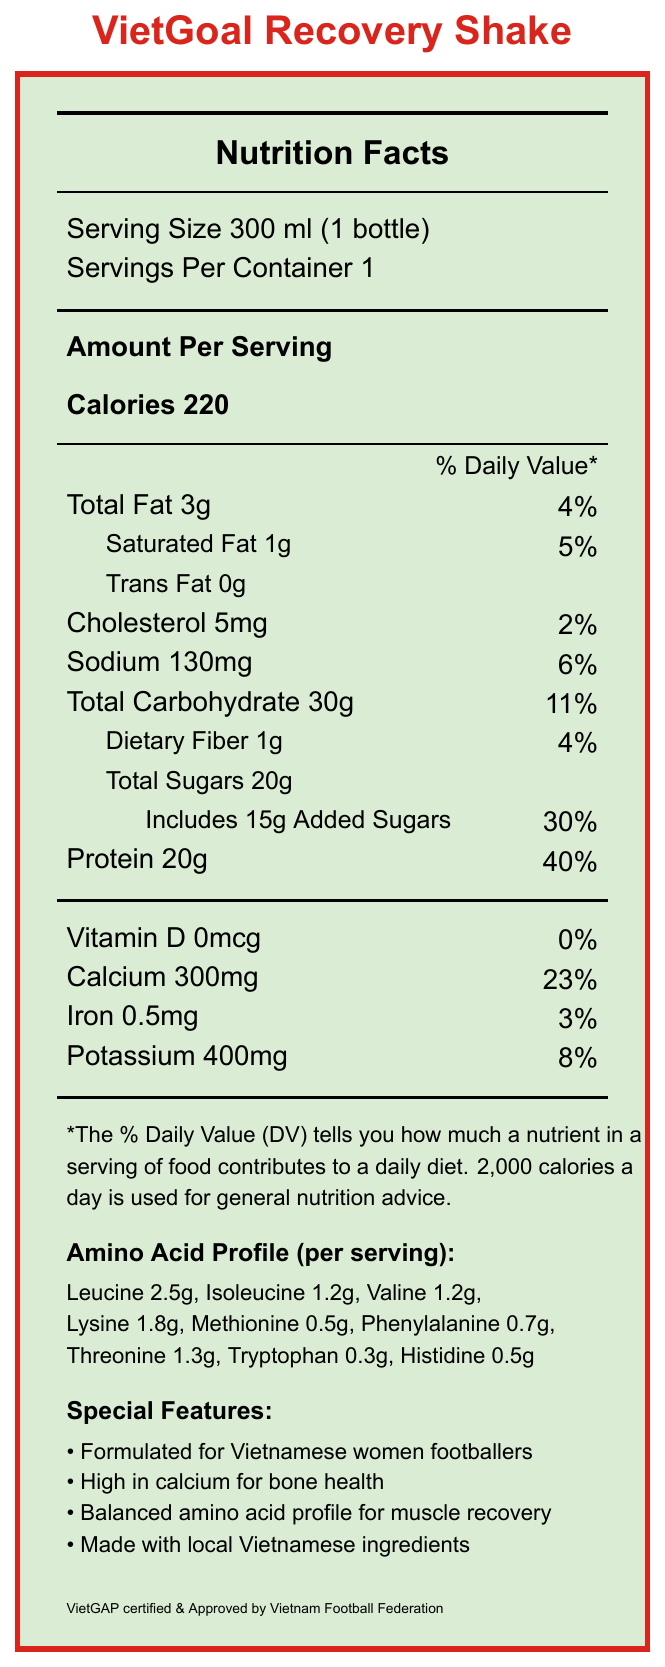what is the serving size? The serving size information is listed in the document as 300 ml (1 bottle).
Answer: 300 ml (1 bottle) how much calcium is in one serving of VietGoal Recovery Shake? The document states that each serving contains 300 mg of calcium.
Answer: 300 mg what is the daily value percentage for protein? The daily value percentage for protein is given as %40 in the nutrition facts section.
Answer: 40% which amino acids are listed in the amino acid profile? The document provides a detailed list of amino acids and their respective amounts in the amino acid profile section.
Answer: Leucine, Isoleucine, Valine, Lysine, Methionine, Phenylalanine, Threonine, Tryptophan, Histidine how many grams of dietary fiber does one serving of the shake contain? The dietary fiber content in one serving is mentioned as 1g.
Answer: 1g what is the percentage of daily value for calcium? The daily value percentage for calcium is shown as 23% in the nutrition facts section.
Answer: 23% how many grams of total sugars are in one serving? The total sugars content per serving is listed at 20g in the nutrition facts.
Answer: 20g does the product contain any trans fats? The document indicates that the amount of trans fat per serving is 0g.
Answer: No how many mg of potassium does the shake contain per serving? The potassium content per serving is stated as 400 mg.
Answer: 400 mg who manufactures the VietGoal Recovery Shake? The document specifies that the product is produced by VietNam Sports Nutrition Co., Ltd., Ho Chi Minh City, Vietnam.
Answer: VietNam Sports Nutrition Co., Ltd. what is the protein content of the shake? A. 10g B. 15g C. 20g D. 25g The document lists the protein content of one serving as 20g.
Answer: C which of these special features is mentioned in the document? A. Gluten-free B. Formulated for Vietnamese women footballers C. High in vitamin D D. Contains no added sugars The document highlights that it is formulated for Vietnamese women footballers among the special features.
Answer: B is the product approved by the Vietnam Football Federation? The document indicates that the product is approved by the Vietnam Football Federation.
Answer: Yes summarize this document. The document outlines key nutritional components of the shake, emphasizing the product's suitability for athletes, especially mentioning its calcium and amino acid profile tailored for muscle recovery and bone health.
Answer: It describes the nutrition facts and special features of the VietGoal Recovery Shake, a product designed for Vietnamese women footballers. It provides detailed information about the serving size, calories, macronutrient content, and vitamins and minerals, with an emphasis on a balanced amino acid profile and high calcium content. The document also includes details about the special features and the manufacturer. where is the manufacturer located? The manufacturer's location is stated as Ho Chi Minh City, Vietnam.
Answer: Ho Chi Minh City, Vietnam what ingredients are in the shake? The ingredients list provides detailed information about what is contained in the shake.
Answer: Filtered water, whey protein isolate, maltodextrin, cane sugar, coconut milk, natural flavors, soy lecithin, carrageenan, salt, stevia leaf extract what is the total carbohydrate content per serving? The total carbohydrate content per serving is given as 30g.
Answer: 30g how much leucine does one serving of the shake contain? The amino acid profile lists leucine content as 2.5g per serving.
Answer: 2.5g is the product high in vitamin D? Why or why not? The document indicates that the vitamin D content is 0mcg, contributing 0% to the daily value, hence it is not high in vitamin D.
Answer: No does the document provide any information about gluten content? The document does not mention anything about the gluten content, so this information cannot be determined based on the text provided.
Answer: No 